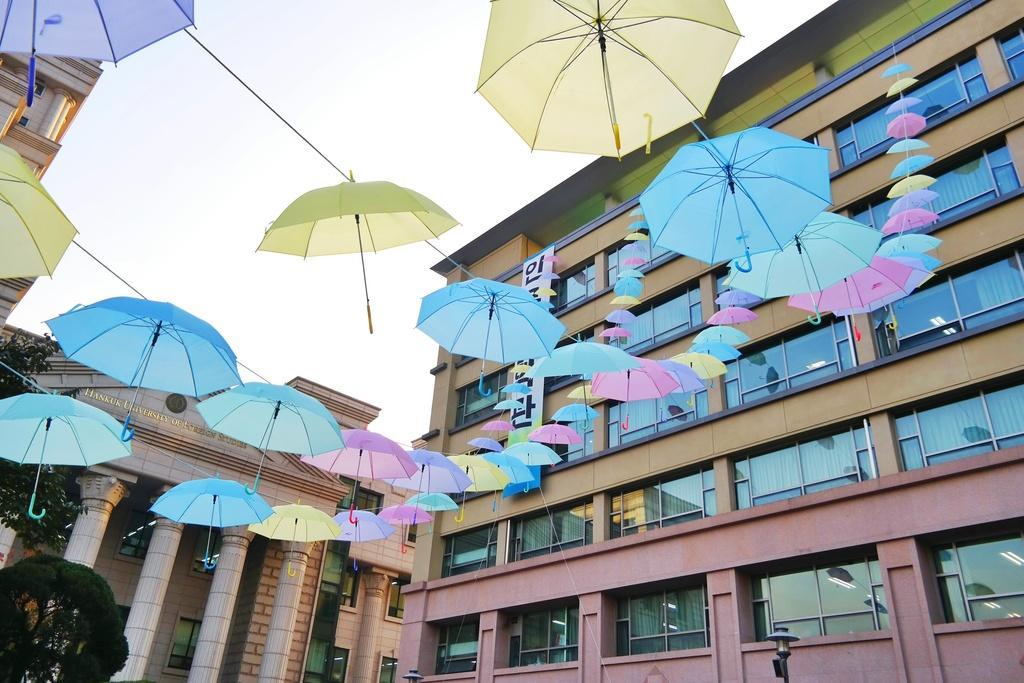In one or two sentences, can you explain what this image depicts? In this image I can see few umbrellas in pink, blue and yellow color. In the background I can see few buildings in brown color and the sky is in white color. 